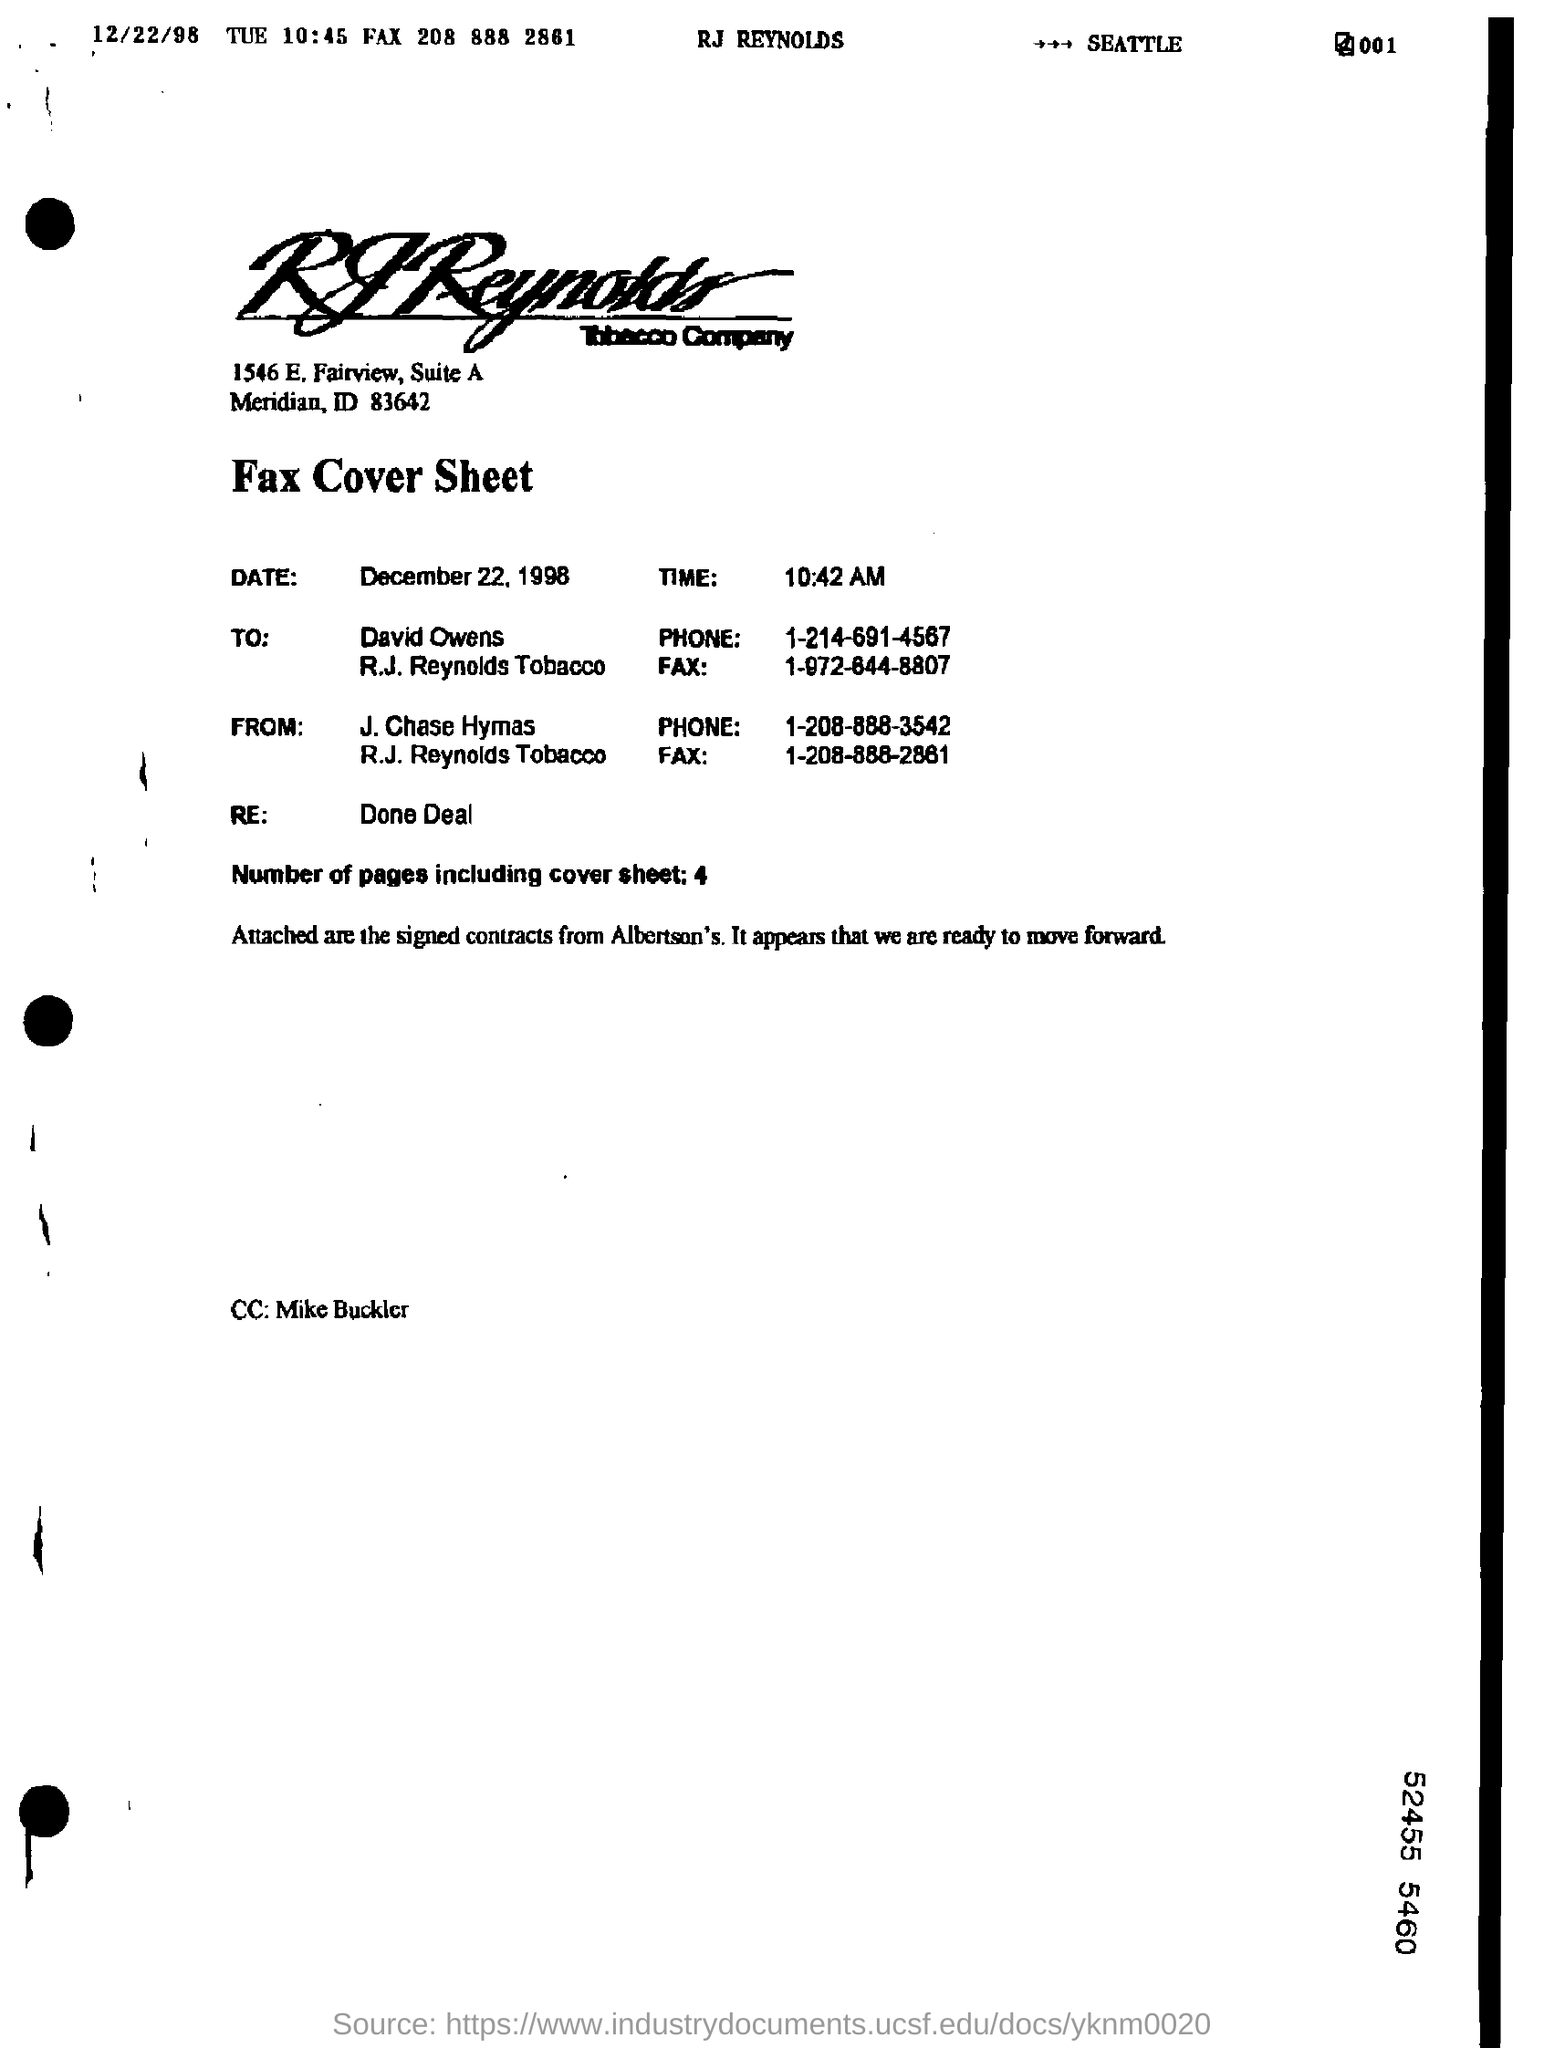Draw attention to some important aspects in this diagram. The time mentioned in the fax cover sheet is 10:42 AM. The fax is being sent to David Owens. The CC of the fax is Mike Buckler. The sender of this FAX is J. Chase Hymas. There are four pages in the fax, including the cover sheet. 